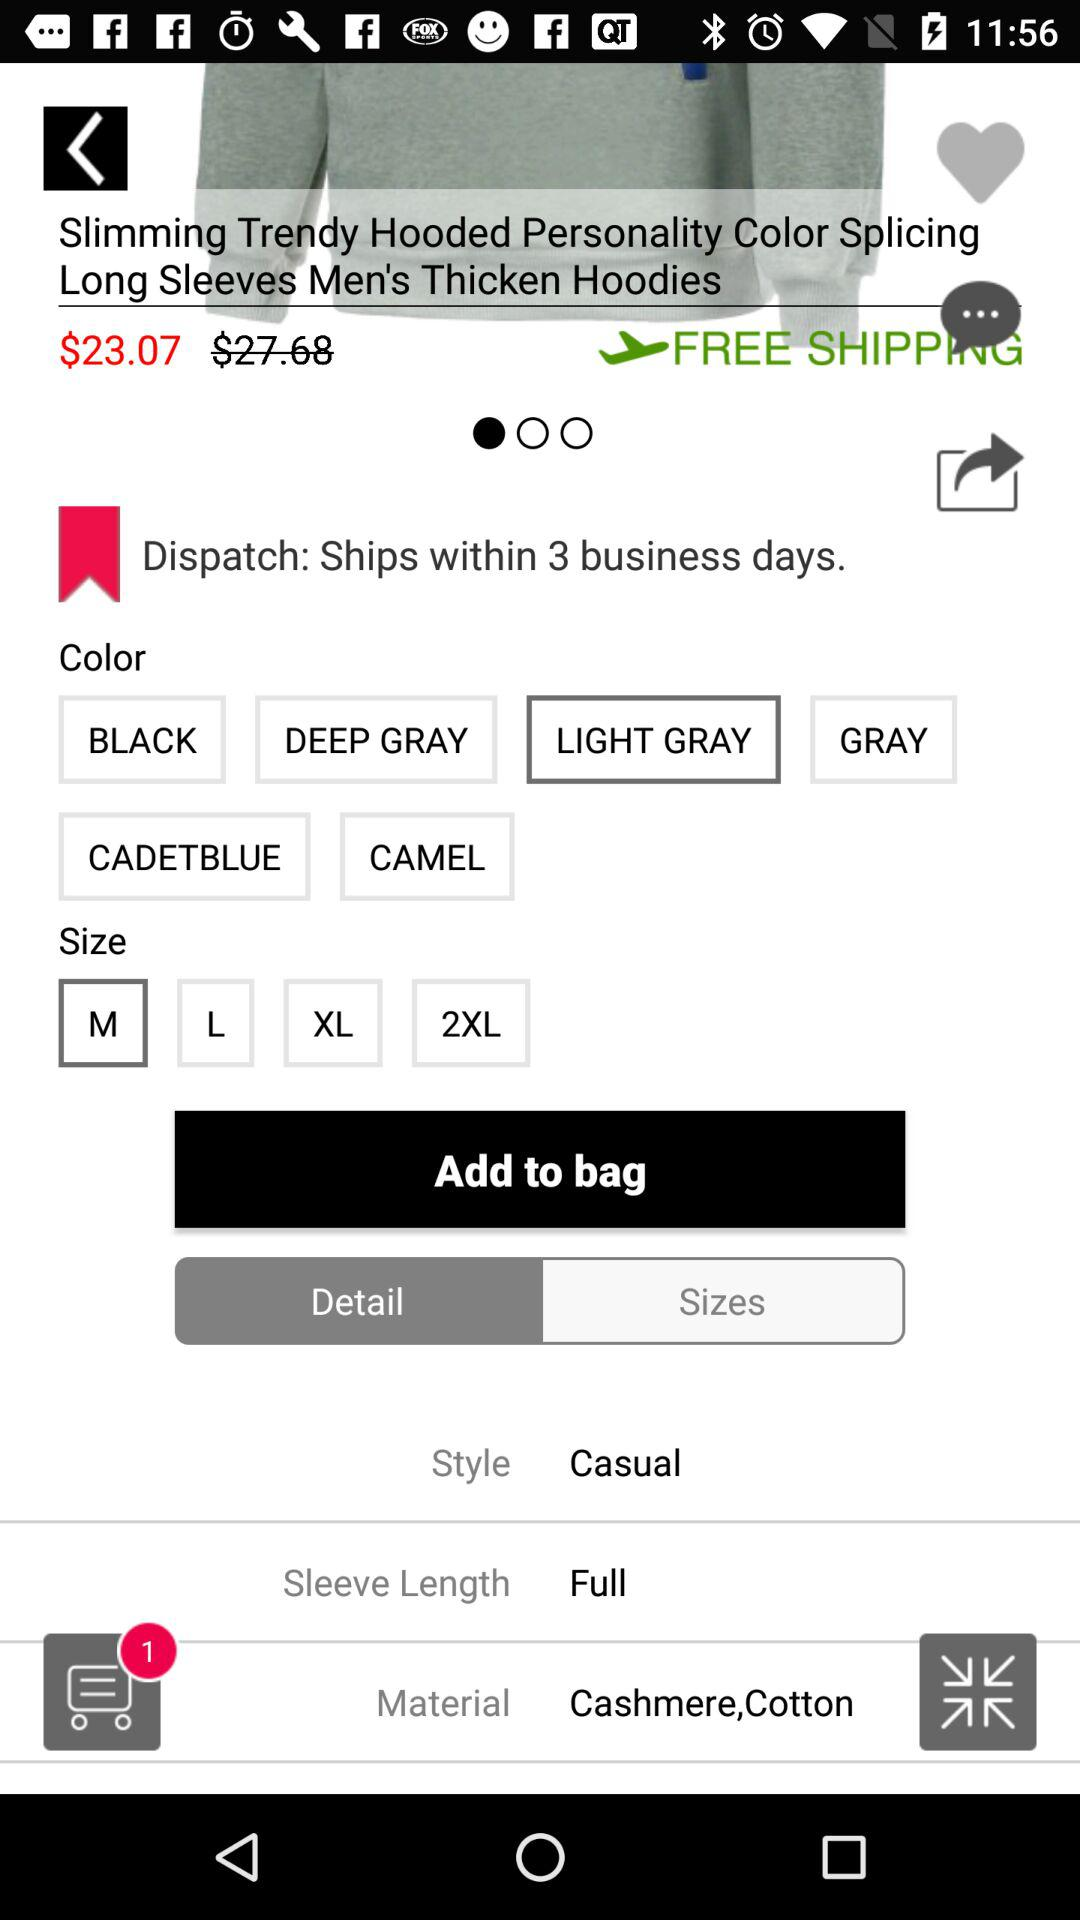What is the discounted price? The discounted price is $23.07. 